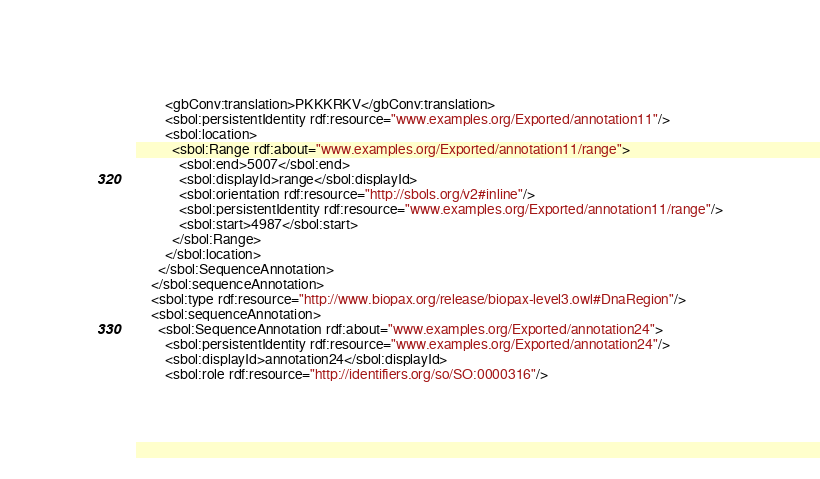Convert code to text. <code><loc_0><loc_0><loc_500><loc_500><_XML_>        <gbConv:translation>PKKKRKV</gbConv:translation>
        <sbol:persistentIdentity rdf:resource="www.examples.org/Exported/annotation11"/>
        <sbol:location>
          <sbol:Range rdf:about="www.examples.org/Exported/annotation11/range">
            <sbol:end>5007</sbol:end>
            <sbol:displayId>range</sbol:displayId>
            <sbol:orientation rdf:resource="http://sbols.org/v2#inline"/>
            <sbol:persistentIdentity rdf:resource="www.examples.org/Exported/annotation11/range"/>
            <sbol:start>4987</sbol:start>
          </sbol:Range>
        </sbol:location>
      </sbol:SequenceAnnotation>
    </sbol:sequenceAnnotation>
    <sbol:type rdf:resource="http://www.biopax.org/release/biopax-level3.owl#DnaRegion"/>
    <sbol:sequenceAnnotation>
      <sbol:SequenceAnnotation rdf:about="www.examples.org/Exported/annotation24">
        <sbol:persistentIdentity rdf:resource="www.examples.org/Exported/annotation24"/>
        <sbol:displayId>annotation24</sbol:displayId>
        <sbol:role rdf:resource="http://identifiers.org/so/SO:0000316"/></code> 